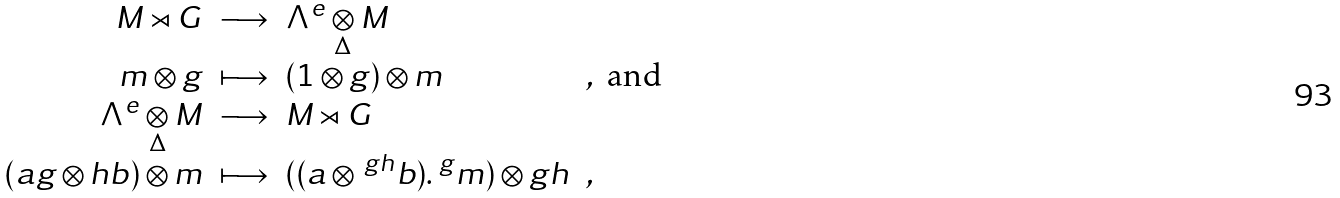<formula> <loc_0><loc_0><loc_500><loc_500>\begin{array} { r c l l } M \rtimes G & \longrightarrow & \Lambda ^ { e } \underset { \Delta } { \otimes } M \\ m \otimes g & \longmapsto & ( 1 \otimes g ) \otimes m & , \ \text {and} \\ \Lambda ^ { e } \underset { \Delta } { \otimes } M & \longrightarrow & M \rtimes G \\ ( a g \otimes h b ) \otimes m & \longmapsto & ( ( a \otimes \, ^ { g h } b ) . \, ^ { g } m ) \otimes g h & , \end{array}</formula> 